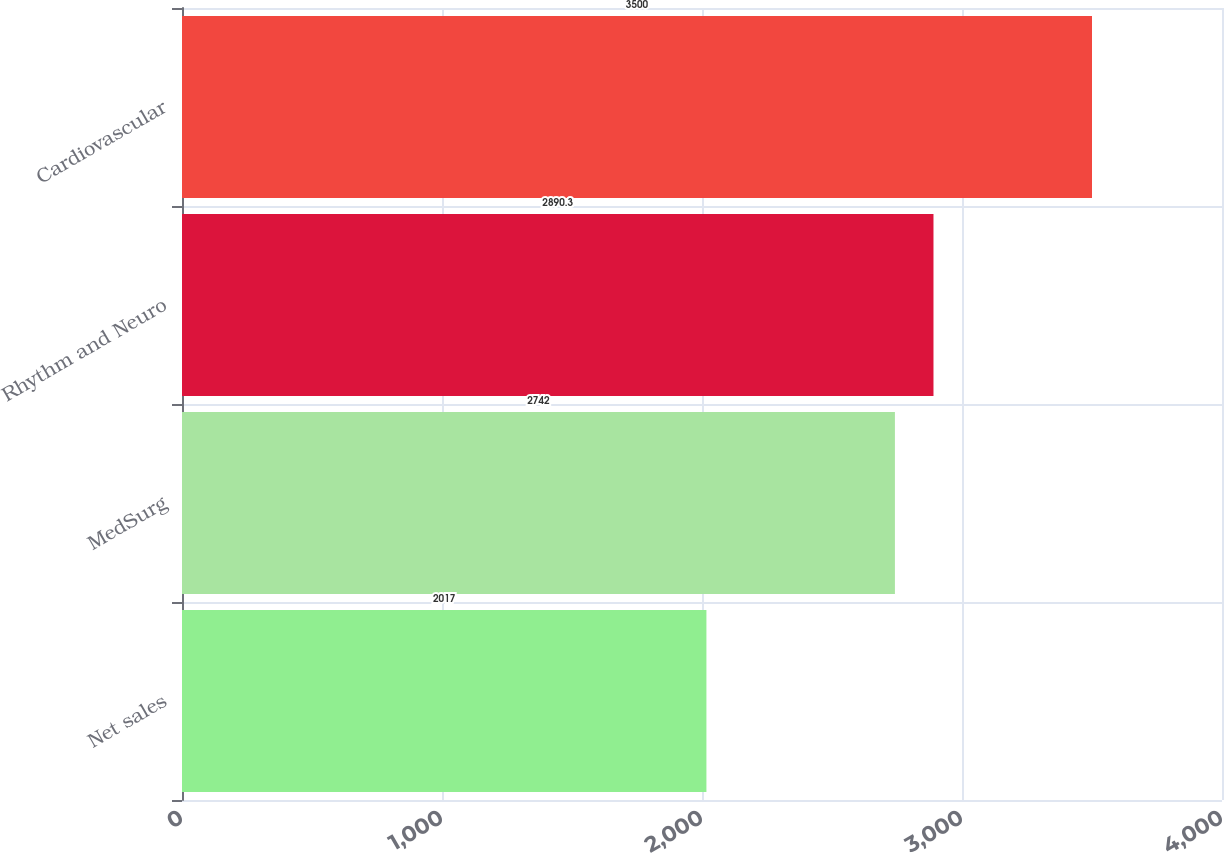Convert chart. <chart><loc_0><loc_0><loc_500><loc_500><bar_chart><fcel>Net sales<fcel>MedSurg<fcel>Rhythm and Neuro<fcel>Cardiovascular<nl><fcel>2017<fcel>2742<fcel>2890.3<fcel>3500<nl></chart> 